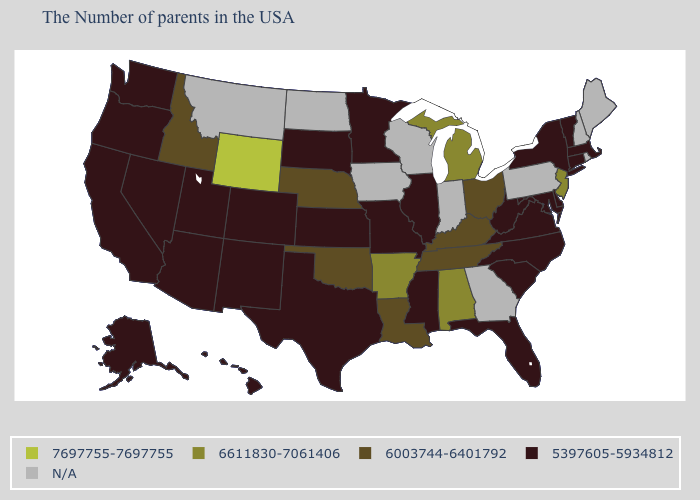Among the states that border Nebraska , which have the highest value?
Concise answer only. Wyoming. Does Louisiana have the highest value in the South?
Answer briefly. No. What is the highest value in the USA?
Short answer required. 7697755-7697755. Which states have the lowest value in the USA?
Be succinct. Massachusetts, Vermont, Connecticut, New York, Delaware, Maryland, Virginia, North Carolina, South Carolina, West Virginia, Florida, Illinois, Mississippi, Missouri, Minnesota, Kansas, Texas, South Dakota, Colorado, New Mexico, Utah, Arizona, Nevada, California, Washington, Oregon, Alaska, Hawaii. What is the value of Washington?
Keep it brief. 5397605-5934812. Name the states that have a value in the range 7697755-7697755?
Give a very brief answer. Wyoming. Does the map have missing data?
Give a very brief answer. Yes. Which states have the lowest value in the USA?
Write a very short answer. Massachusetts, Vermont, Connecticut, New York, Delaware, Maryland, Virginia, North Carolina, South Carolina, West Virginia, Florida, Illinois, Mississippi, Missouri, Minnesota, Kansas, Texas, South Dakota, Colorado, New Mexico, Utah, Arizona, Nevada, California, Washington, Oregon, Alaska, Hawaii. Name the states that have a value in the range 7697755-7697755?
Quick response, please. Wyoming. How many symbols are there in the legend?
Concise answer only. 5. Name the states that have a value in the range N/A?
Concise answer only. Maine, Rhode Island, New Hampshire, Pennsylvania, Georgia, Indiana, Wisconsin, Iowa, North Dakota, Montana. What is the lowest value in the South?
Concise answer only. 5397605-5934812. Name the states that have a value in the range 5397605-5934812?
Concise answer only. Massachusetts, Vermont, Connecticut, New York, Delaware, Maryland, Virginia, North Carolina, South Carolina, West Virginia, Florida, Illinois, Mississippi, Missouri, Minnesota, Kansas, Texas, South Dakota, Colorado, New Mexico, Utah, Arizona, Nevada, California, Washington, Oregon, Alaska, Hawaii. 